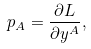<formula> <loc_0><loc_0><loc_500><loc_500>p _ { A } = \frac { \partial L } { \partial y ^ { A } } ,</formula> 